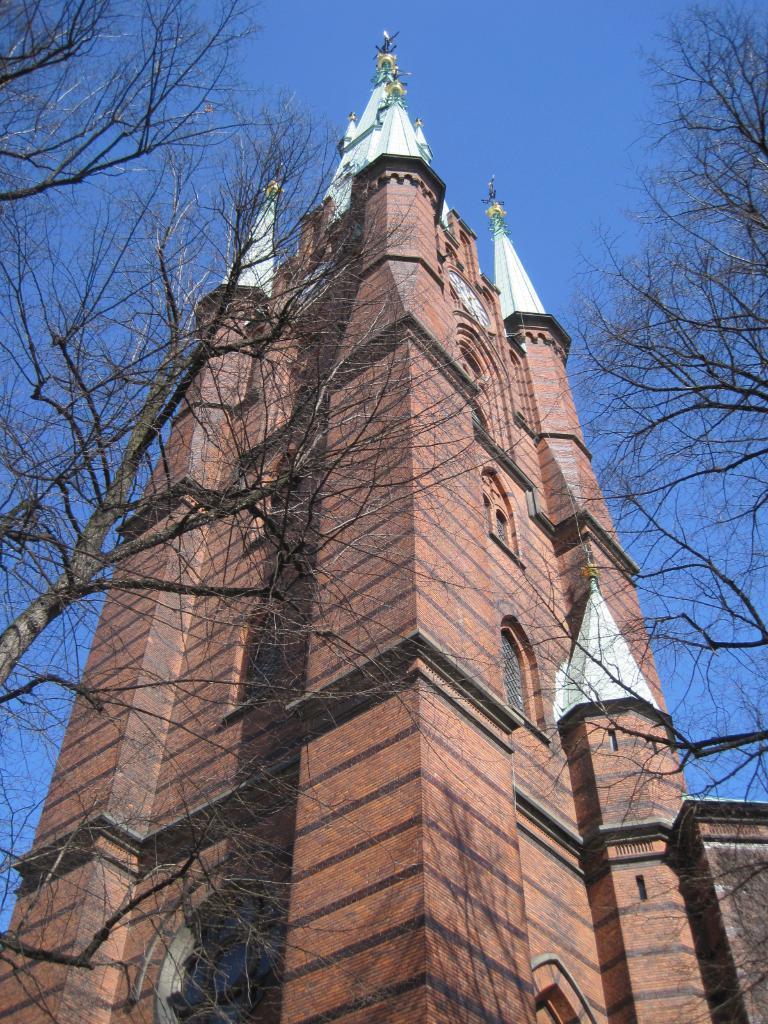Can you describe this image briefly? In this image I can see in the middle there is a big building, there are trees on either side of this image and at the top it is the sky. 